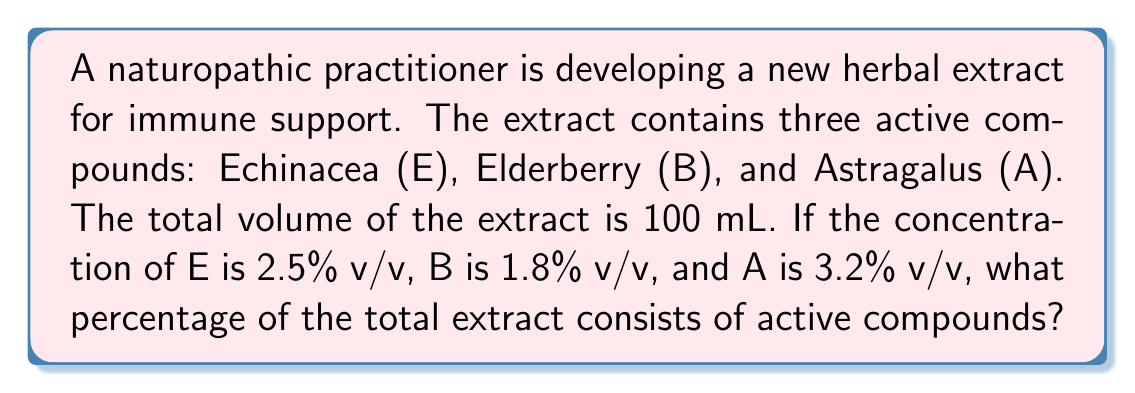Can you solve this math problem? To solve this problem, we need to:
1. Understand that the concentrations are given in volume/volume percentage (v/v%).
2. Add the individual percentages of the active compounds.
3. Calculate the total percentage of active compounds in the extract.

Let's break it down step-by-step:

1. Given concentrations:
   Echinacea (E): 2.5% v/v
   Elderberry (B): 1.8% v/v
   Astragalus (A): 3.2% v/v

2. To find the total percentage of active compounds, we simply add these percentages:

   $$\text{Total % of active compounds} = \text{% of E} + \text{% of B} + \text{% of A}$$

3. Substituting the values:

   $$\text{Total % of active compounds} = 2.5\% + 1.8\% + 3.2\%$$

4. Performing the addition:

   $$\text{Total % of active compounds} = 7.5\%$$

Therefore, the total percentage of active compounds in the herbal extract is 7.5%.
Answer: 7.5% 